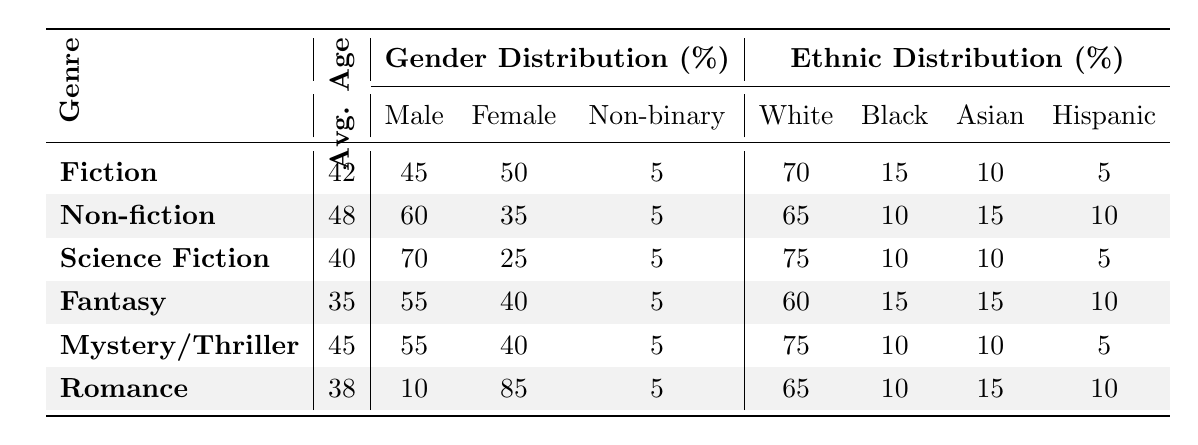What is the average age of authors in the Romance genre? The table indicates that the average age of authors in the Romance genre is listed under the Avg. Age column, which shows 38 years.
Answer: 38 Which genre has the highest percentage of female authors? By examining the Gender Distribution section, the Romance genre shows 85% female authors, higher than any other genre.
Answer: Romance What is the percentage of male authors in Science Fiction? The Gender Distribution for Science Fiction indicates that male authors constitute 70% of the total.
Answer: 70 What is the average age difference between authors in Fiction and Non-fiction? The average age of Fiction authors is 42 years, and for Non-fiction, it is 48 years. The difference is calculated as 48 - 42 = 6 years.
Answer: 6 Is the percentage of Black authors in Fantasy higher than in Romance? The percentage of Black authors in Fantasy is 15%, while in Romance it is 10%. Since 15% is greater than 10%, the statement is true.
Answer: Yes What is the total percentage of male and female authors in Mystery/Thriller combined? For Mystery/Thriller, the male authors make up 55% and female authors make up 40%. Combining these gives 55 + 40 = 95%.
Answer: 95 Which genre has the lowest average age of authors? Comparing all average ages, Fantasy at 35 years is the lowest age compared to others like Fiction (42) and Non-fiction (48).
Answer: Fantasy How many genres have a non-binary author percentage of 5%? All genres listed have a non-binary author percentage of 5%, which means every genre (Fiction, Non-fiction, Science Fiction, Fantasy, Mystery/Thriller, and Romance) has this same percentage. Therefore, there are 6 genres.
Answer: 6 What percentage of authors in Fiction belong to the White ethnic group? The Ethnic Distribution for Fiction shows that White authors make up 70% of the total authors in that genre.
Answer: 70 If you look at the ethnic distribution of Non-fiction, which ethnicity has the second highest percentage? The table indicates that in Non-fiction, White authors (65%) have the highest percentage, followed by Asian authors (15%), which is the second highest.
Answer: Asian 